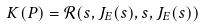<formula> <loc_0><loc_0><loc_500><loc_500>K ( P ) = \mathcal { R } ( s , J _ { E } ( s ) , s , J _ { E } ( s ) )</formula> 